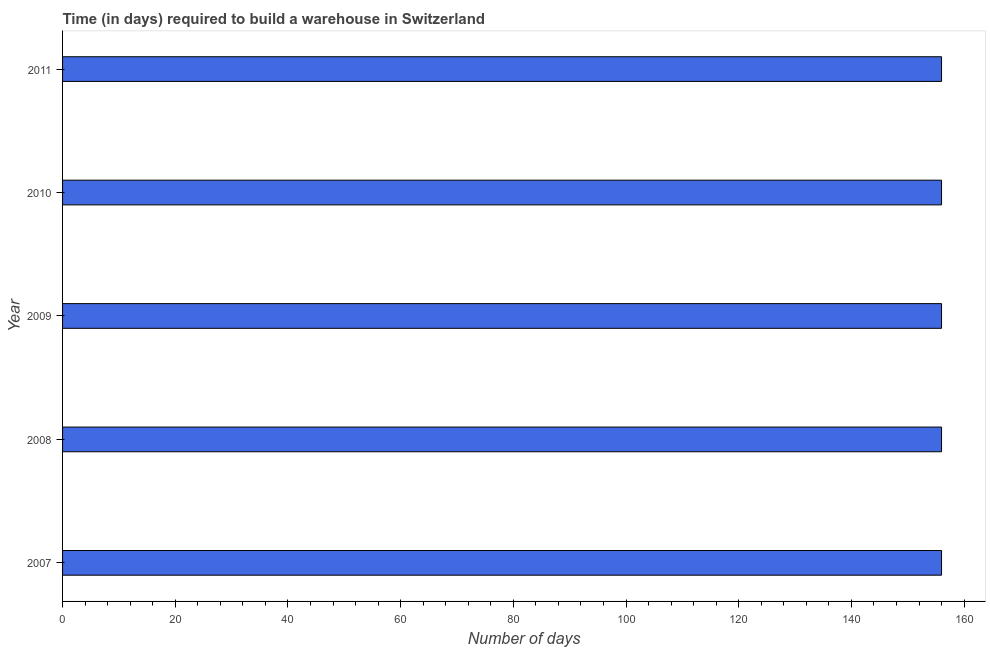What is the title of the graph?
Provide a succinct answer. Time (in days) required to build a warehouse in Switzerland. What is the label or title of the X-axis?
Make the answer very short. Number of days. What is the time required to build a warehouse in 2008?
Provide a succinct answer. 156. Across all years, what is the maximum time required to build a warehouse?
Give a very brief answer. 156. Across all years, what is the minimum time required to build a warehouse?
Keep it short and to the point. 156. In which year was the time required to build a warehouse minimum?
Offer a very short reply. 2007. What is the sum of the time required to build a warehouse?
Offer a very short reply. 780. What is the average time required to build a warehouse per year?
Provide a short and direct response. 156. What is the median time required to build a warehouse?
Your answer should be very brief. 156. In how many years, is the time required to build a warehouse greater than 52 days?
Your answer should be compact. 5. Is the time required to build a warehouse in 2007 less than that in 2010?
Your answer should be very brief. No. What is the difference between the highest and the second highest time required to build a warehouse?
Your response must be concise. 0. What is the difference between the highest and the lowest time required to build a warehouse?
Your answer should be compact. 0. In how many years, is the time required to build a warehouse greater than the average time required to build a warehouse taken over all years?
Your answer should be compact. 0. Are all the bars in the graph horizontal?
Make the answer very short. Yes. How many years are there in the graph?
Your answer should be compact. 5. What is the Number of days of 2007?
Provide a short and direct response. 156. What is the Number of days of 2008?
Provide a succinct answer. 156. What is the Number of days of 2009?
Offer a terse response. 156. What is the Number of days of 2010?
Your answer should be compact. 156. What is the Number of days in 2011?
Offer a very short reply. 156. What is the difference between the Number of days in 2008 and 2011?
Offer a very short reply. 0. What is the difference between the Number of days in 2010 and 2011?
Make the answer very short. 0. What is the ratio of the Number of days in 2007 to that in 2008?
Ensure brevity in your answer.  1. What is the ratio of the Number of days in 2007 to that in 2009?
Your answer should be compact. 1. What is the ratio of the Number of days in 2007 to that in 2010?
Offer a very short reply. 1. What is the ratio of the Number of days in 2007 to that in 2011?
Your response must be concise. 1. What is the ratio of the Number of days in 2008 to that in 2009?
Make the answer very short. 1. What is the ratio of the Number of days in 2008 to that in 2010?
Give a very brief answer. 1. What is the ratio of the Number of days in 2009 to that in 2010?
Your response must be concise. 1. What is the ratio of the Number of days in 2010 to that in 2011?
Offer a very short reply. 1. 